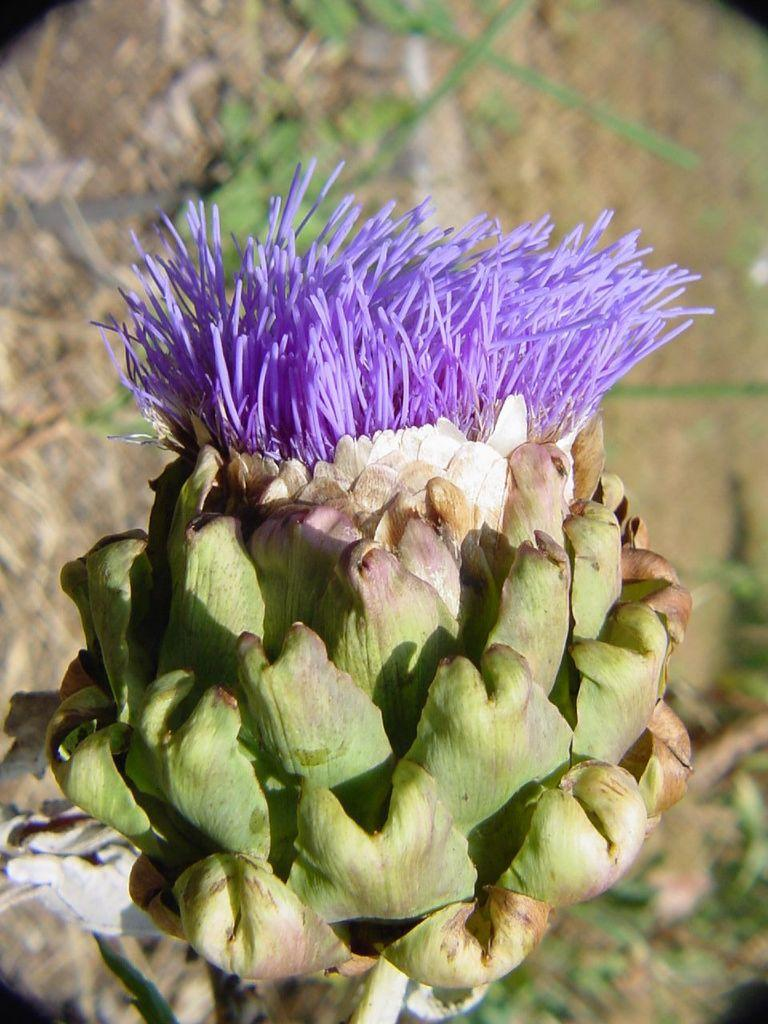What is the main subject of the image? There is a flower in the image. What is the color of the flower? The flower is purple in color. What else can be seen in the image besides the flower? There are leaves in the image. What is the color of the leaves? The leaves are green in color. How many spiders are crawling on the flower in the image? There are no spiders present in the image; it features a flower and leaves. What type of machine is visible in the image? There is no machine present in the image. 